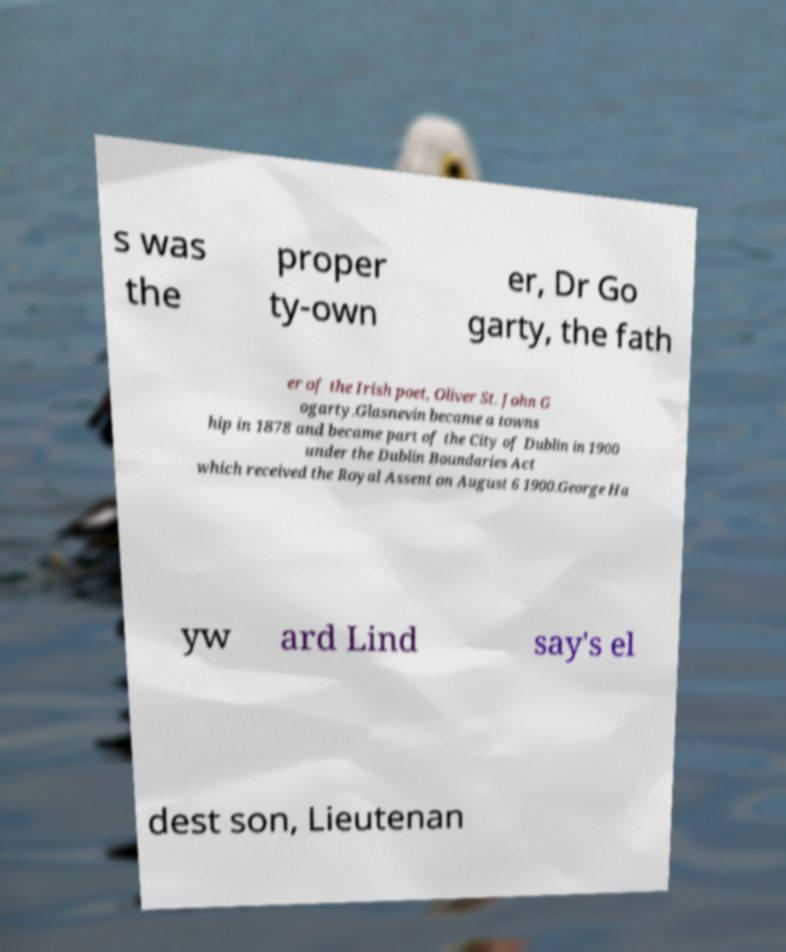Please read and relay the text visible in this image. What does it say? s was the proper ty-own er, Dr Go garty, the fath er of the Irish poet, Oliver St. John G ogarty.Glasnevin became a towns hip in 1878 and became part of the City of Dublin in 1900 under the Dublin Boundaries Act which received the Royal Assent on August 6 1900.George Ha yw ard Lind say's el dest son, Lieutenan 